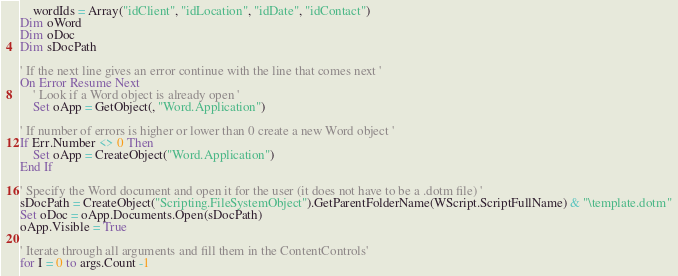Convert code to text. <code><loc_0><loc_0><loc_500><loc_500><_VisualBasic_>	wordIds = Array("idClient", "idLocation", "idDate", "idContact")
Dim oWord
Dim oDoc
Dim sDocPath

' If the next line gives an error continue with the line that comes next '
On Error Resume Next
	' Look if a Word object is already open '
	Set oApp = GetObject(, "Word.Application")

' If number of errors is higher or lower than 0 create a new Word object '
If Err.Number <> 0 Then
	Set oApp = CreateObject("Word.Application")
End If

' Specify the Word document and open it for the user (it does not have to be a .dotm file) '
sDocPath = CreateObject("Scripting.FileSystemObject").GetParentFolderName(WScript.ScriptFullName) & "\template.dotm"
Set oDoc = oApp.Documents.Open(sDocPath)
oApp.Visible = True

' Iterate through all arguments and fill them in the ContentControls'
for I = 0 to args.Count -1</code> 